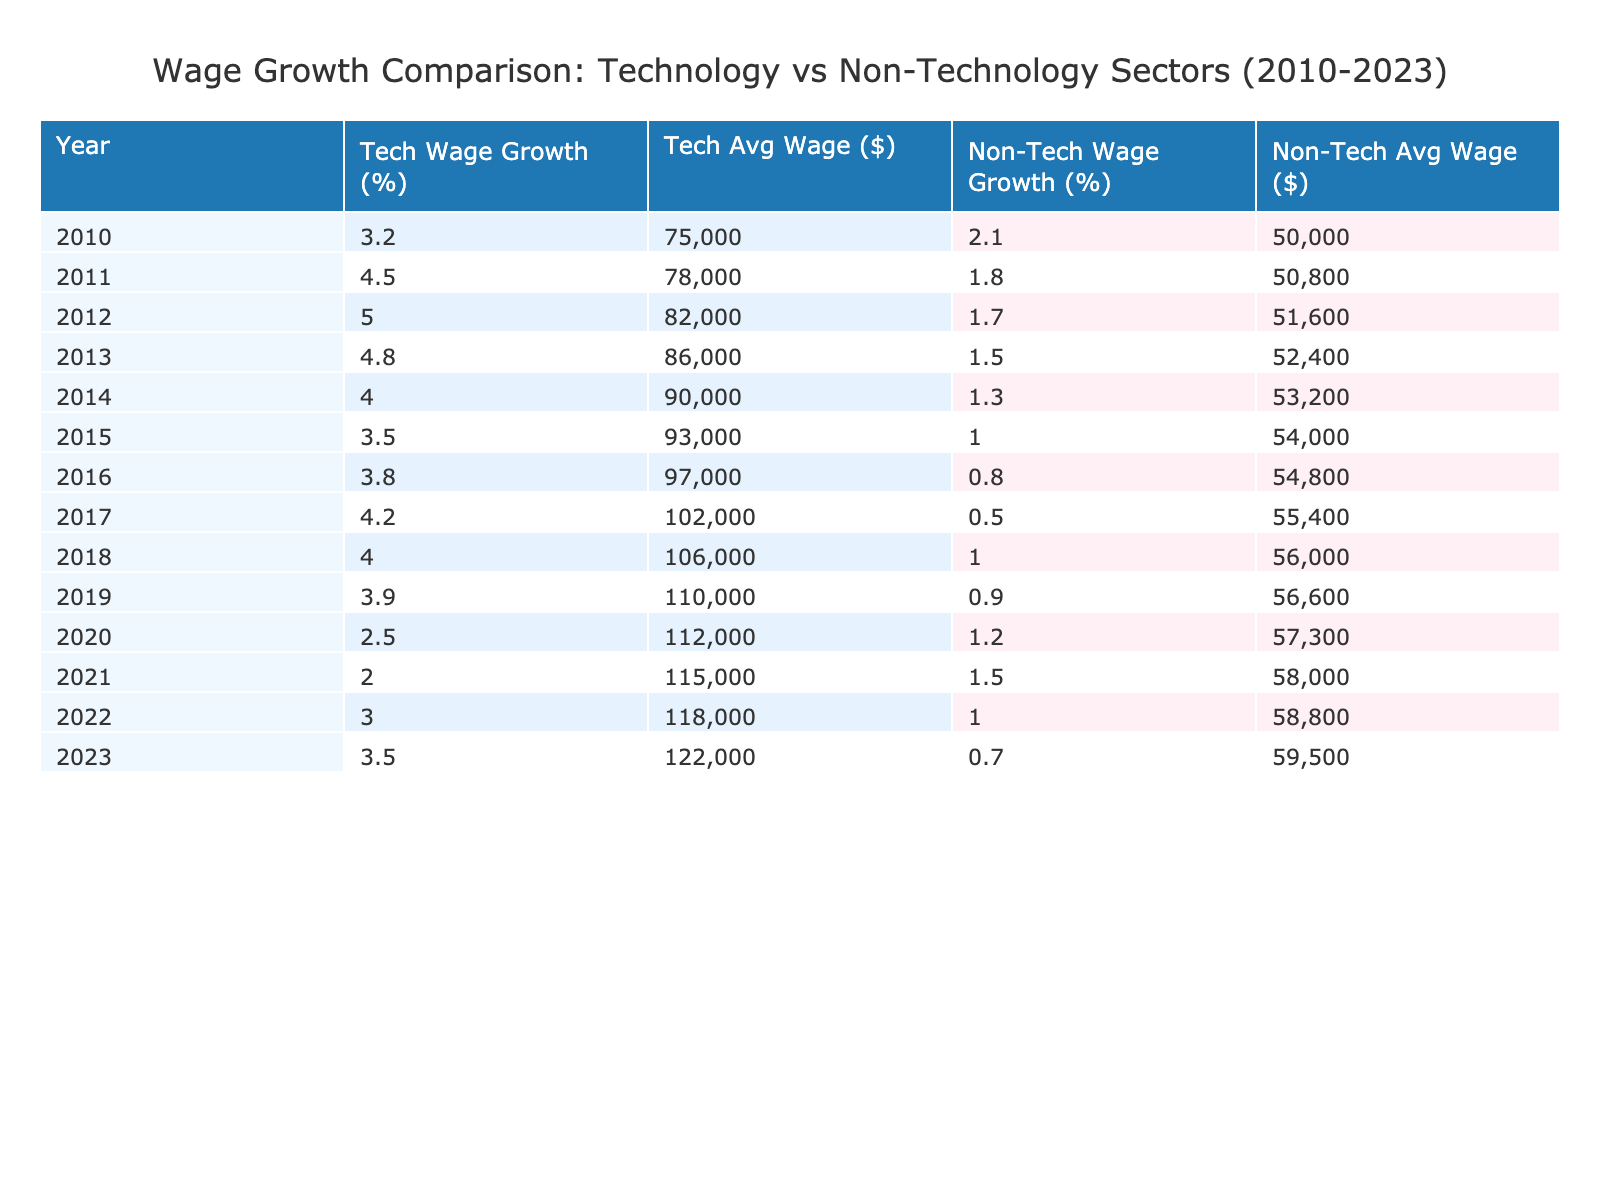What was the average wage in the Technology sector in 2015? The table indicates that the average wage for the Technology sector in 2015 was 93,000 USD. This value can be directly retrieved from the "Average Wage (USD)" column for the year 2015 under the Technology sector.
Answer: 93,000 USD What was the highest wage growth percentage in the Non-Technology sector during this period? Examining the "Wage Growth (%)" column for the Non-Technology sector reveals the highest value was 2.1%, which occurred in 2010. This is the maximum value when comparing all years listed for this sector.
Answer: 2.1% What was the wage growth difference between Technology and Non-Technology sectors in 2020? In 2020, wage growth for Technology was 2.5% and for Non-Technology was 1.2%. The difference can be calculated as 2.5% - 1.2% = 1.3%.
Answer: 1.3% Was the average wage in the Non-Technology sector higher than 60,000 USD in 2019? In the Non-Technology sector for the year 2019, the average wage was recorded as 56,600 USD. Since this is less than 60,000 USD, the answer is no.
Answer: No What was the average wage growth for the Technology sector over the entire 2010-2023 period? To find the average wage growth, we sum all the wage growth percentages for the Technology sector from 2010 to 2023. The values are 3.2, 4.5, 5.0, 4.8, 4.0, 3.5, 3.8, 4.2, 4.0, 3.9, 2.5, 2.0, 3.0, and 3.5, which totals 53.4%. We then divide this sum by the number of years, which is 14, resulting in an average of 3.814%.
Answer: Approximately 3.8% What was the trend of wage growth in the Technology sector from 2010 to 2023? The trend shows fluctuations in wage growth, peaking at 5.0% in 2012 and generally declining thereafter, with the lowest growth of 2.0% observed in 2021. Analyzing the data shows that overall wage growth has decreased despite still remaining higher than the Non-Technology sector.
Answer: Decreasing trend with fluctuations Which year had the lowest average wage in the Technology sector? By examining the "Average Wage (USD)" column, the lowest average wage in the Technology sector was found in 2010, recorded at 75,000 USD. This data point is specific to that year and stands out when compared to other years.
Answer: 2010 Has the average wage in the Non-Technology sector consistently increased from 2010 to 2023? The average wages for the Non-Technology sector show that in 2010 it was 50,000 USD, and in 2023 it was 59,500 USD. However, the average wages did not increase consistently every year; in fact, the wage decreased in some years (for example, 0.5% in 2017). Thus, the statement is false.
Answer: No 